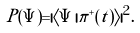Convert formula to latex. <formula><loc_0><loc_0><loc_500><loc_500>P ( \Psi ) = | \langle \Psi | \pi ^ { + } ( t ) \rangle | ^ { 2 } .</formula> 